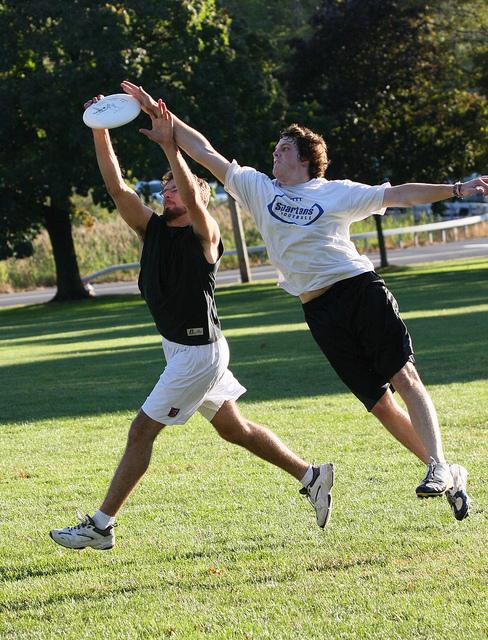The player wearing what color of shirt is likely to catch the frisbee?

Choices:
A) white
B) brown
C) blue
D) black black 